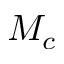Convert formula to latex. <formula><loc_0><loc_0><loc_500><loc_500>M _ { c }</formula> 